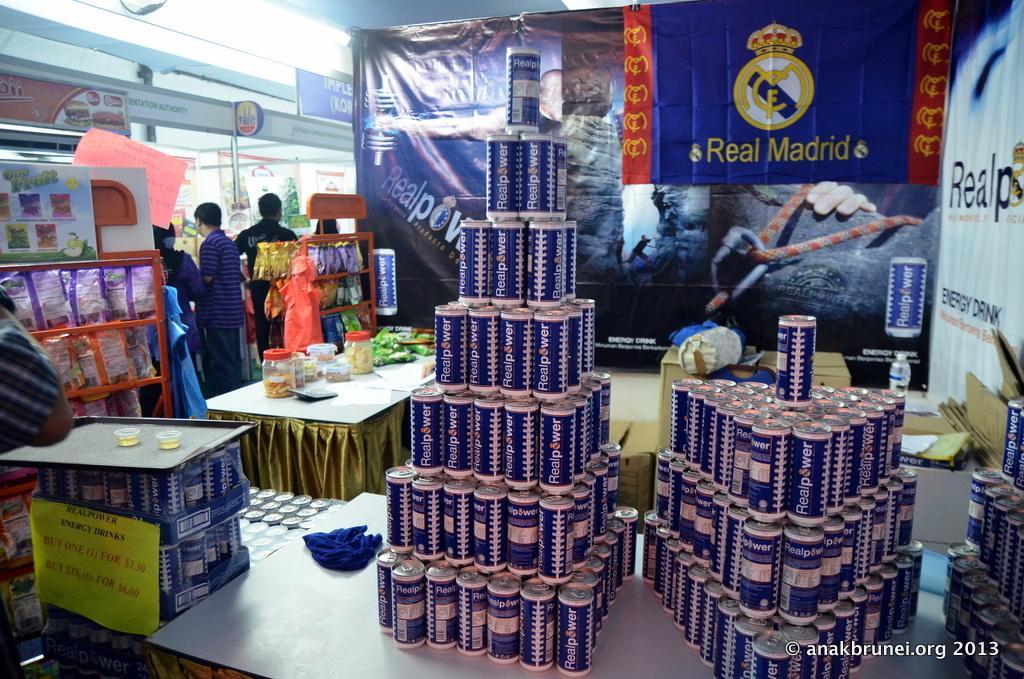In one or two sentences, can you explain what this image depicts? In this image we can see the inside view of the supermarket that includes tin cans, plastic containers and we can also see some products in the racks. 